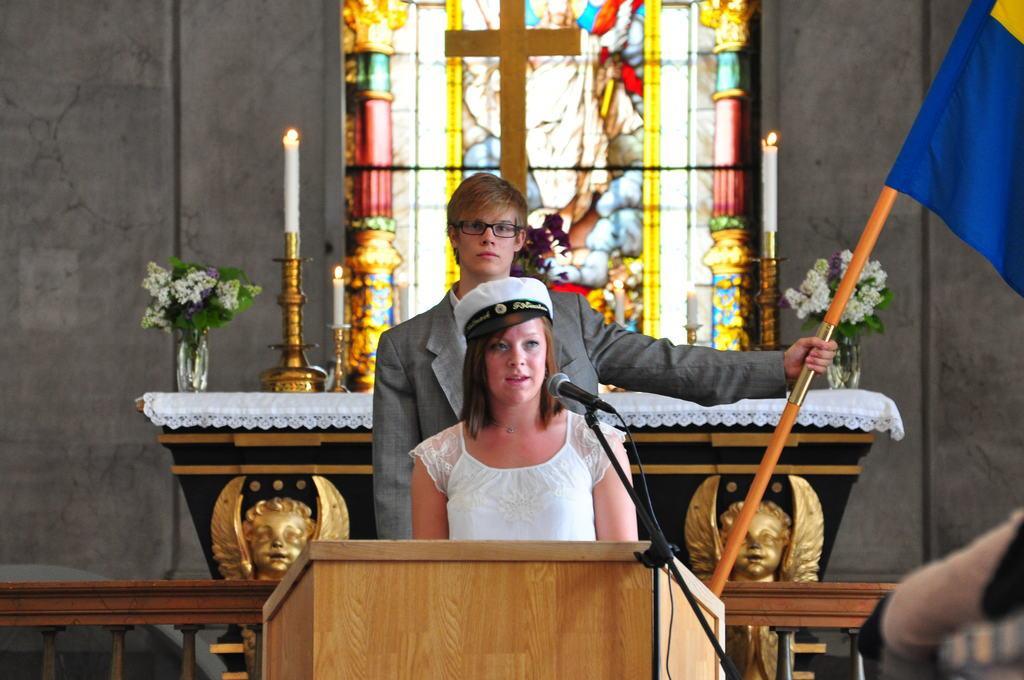Please provide a concise description of this image. In this image I can see a person is standing in front of podium and the person is wearing white dress. I can see a mic, stand. Back I can see a person is holding a flag. I can see few candles, flowers, few objects and the cross symbol. Background is in grey color. 